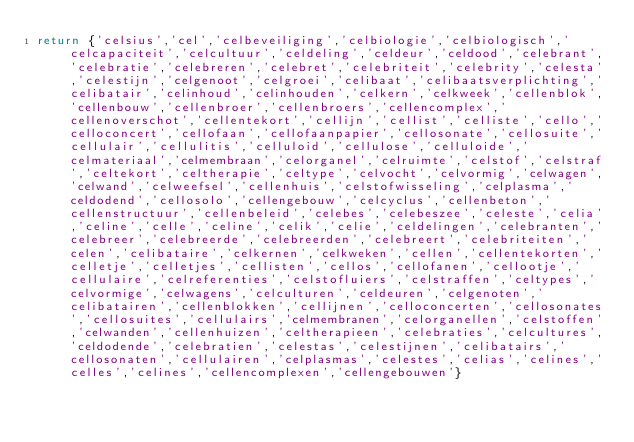<code> <loc_0><loc_0><loc_500><loc_500><_Lua_>return {'celsius','cel','celbeveiliging','celbiologie','celbiologisch','celcapaciteit','celcultuur','celdeling','celdeur','celdood','celebrant','celebratie','celebreren','celebret','celebriteit','celebrity','celesta','celestijn','celgenoot','celgroei','celibaat','celibaatsverplichting','celibatair','celinhoud','celinhouden','celkern','celkweek','cellenblok','cellenbouw','cellenbroer','cellenbroers','cellencomplex','cellenoverschot','cellentekort','cellijn','cellist','celliste','cello','celloconcert','cellofaan','cellofaanpapier','cellosonate','cellosuite','cellulair','cellulitis','celluloid','cellulose','celluloide','celmateriaal','celmembraan','celorganel','celruimte','celstof','celstraf','celtekort','celtherapie','celtype','celvocht','celvormig','celwagen','celwand','celweefsel','cellenhuis','celstofwisseling','celplasma','celdodend','cellosolo','cellengebouw','celcyclus','cellenbeton','cellenstructuur','cellenbeleid','celebes','celebeszee','celeste','celia','celine','celle','celine','celik','celie','celdelingen','celebranten','celebreer','celebreerde','celebreerden','celebreert','celebriteiten','celen','celibataire','celkernen','celkweken','cellen','cellentekorten','celletje','celletjes','cellisten','cellos','cellofanen','cellootje','cellulaire','celreferenties','celstofluiers','celstraffen','celtypes','celvormige','celwagens','celculturen','celdeuren','celgenoten','celibatairen','cellenblokken','cellijnen','celloconcerten','cellosonates','cellosuites','cellulairs','celmembranen','celorganellen','celstoffen','celwanden','cellenhuizen','celtherapieen','celebraties','celcultures','celdodende','celebratien','celestas','celestijnen','celibatairs','cellosonaten','cellulairen','celplasmas','celestes','celias','celines','celles','celines','cellencomplexen','cellengebouwen'}</code> 